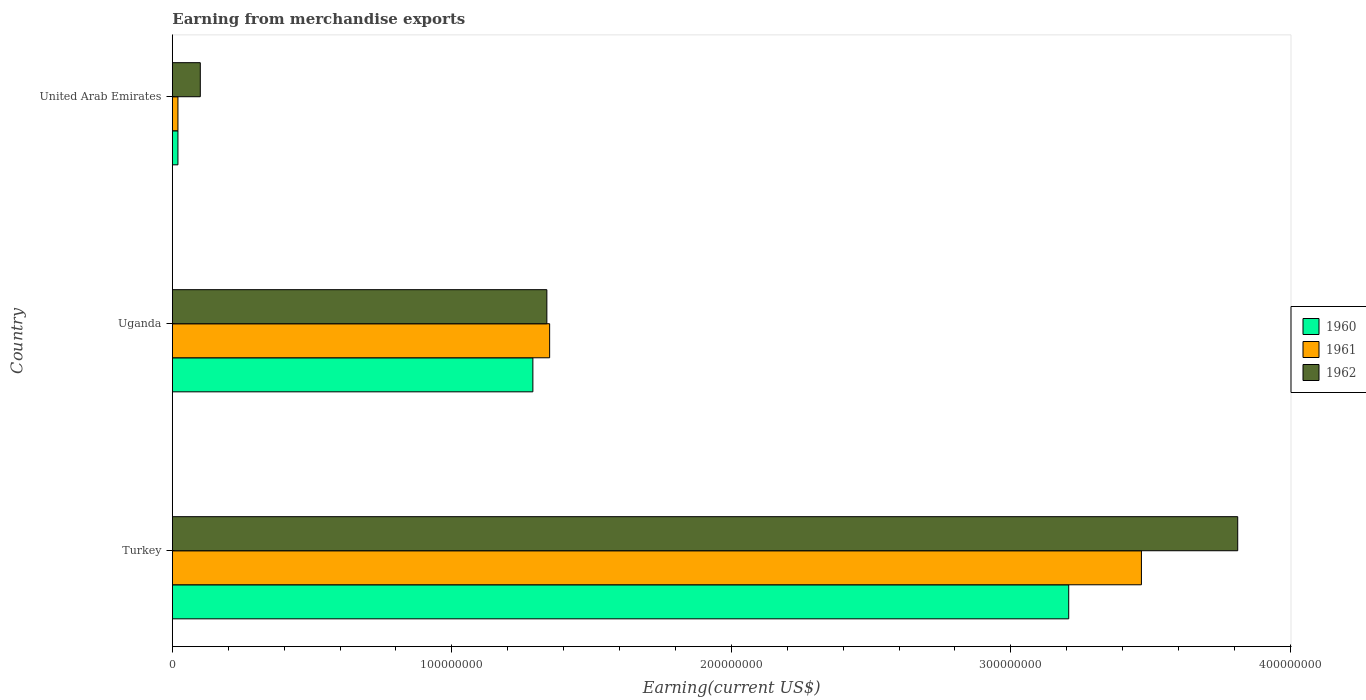How many different coloured bars are there?
Provide a succinct answer. 3. How many groups of bars are there?
Provide a short and direct response. 3. Are the number of bars per tick equal to the number of legend labels?
Offer a very short reply. Yes. Are the number of bars on each tick of the Y-axis equal?
Provide a succinct answer. Yes. How many bars are there on the 3rd tick from the top?
Offer a terse response. 3. How many bars are there on the 1st tick from the bottom?
Provide a succinct answer. 3. What is the label of the 1st group of bars from the top?
Keep it short and to the point. United Arab Emirates. What is the amount earned from merchandise exports in 1962 in Turkey?
Your answer should be very brief. 3.81e+08. Across all countries, what is the maximum amount earned from merchandise exports in 1961?
Your response must be concise. 3.47e+08. Across all countries, what is the minimum amount earned from merchandise exports in 1960?
Provide a succinct answer. 2.00e+06. In which country was the amount earned from merchandise exports in 1961 maximum?
Your response must be concise. Turkey. In which country was the amount earned from merchandise exports in 1962 minimum?
Give a very brief answer. United Arab Emirates. What is the total amount earned from merchandise exports in 1960 in the graph?
Keep it short and to the point. 4.52e+08. What is the difference between the amount earned from merchandise exports in 1961 in Uganda and that in United Arab Emirates?
Provide a short and direct response. 1.33e+08. What is the difference between the amount earned from merchandise exports in 1962 in Uganda and the amount earned from merchandise exports in 1960 in Turkey?
Ensure brevity in your answer.  -1.87e+08. What is the average amount earned from merchandise exports in 1962 per country?
Make the answer very short. 1.75e+08. What is the difference between the amount earned from merchandise exports in 1962 and amount earned from merchandise exports in 1960 in United Arab Emirates?
Ensure brevity in your answer.  8.00e+06. In how many countries, is the amount earned from merchandise exports in 1961 greater than 380000000 US$?
Provide a succinct answer. 0. What is the ratio of the amount earned from merchandise exports in 1960 in Turkey to that in Uganda?
Ensure brevity in your answer.  2.49. Is the amount earned from merchandise exports in 1960 in Uganda less than that in United Arab Emirates?
Your answer should be compact. No. What is the difference between the highest and the second highest amount earned from merchandise exports in 1960?
Offer a very short reply. 1.92e+08. What is the difference between the highest and the lowest amount earned from merchandise exports in 1962?
Your response must be concise. 3.71e+08. What does the 1st bar from the top in Turkey represents?
Give a very brief answer. 1962. What does the 2nd bar from the bottom in Turkey represents?
Make the answer very short. 1961. Does the graph contain any zero values?
Ensure brevity in your answer.  No. Does the graph contain grids?
Ensure brevity in your answer.  No. Where does the legend appear in the graph?
Provide a short and direct response. Center right. How many legend labels are there?
Your answer should be very brief. 3. How are the legend labels stacked?
Give a very brief answer. Vertical. What is the title of the graph?
Your response must be concise. Earning from merchandise exports. What is the label or title of the X-axis?
Offer a terse response. Earning(current US$). What is the Earning(current US$) of 1960 in Turkey?
Provide a succinct answer. 3.21e+08. What is the Earning(current US$) in 1961 in Turkey?
Keep it short and to the point. 3.47e+08. What is the Earning(current US$) in 1962 in Turkey?
Offer a very short reply. 3.81e+08. What is the Earning(current US$) in 1960 in Uganda?
Offer a very short reply. 1.29e+08. What is the Earning(current US$) in 1961 in Uganda?
Give a very brief answer. 1.35e+08. What is the Earning(current US$) of 1962 in Uganda?
Provide a succinct answer. 1.34e+08. What is the Earning(current US$) of 1961 in United Arab Emirates?
Ensure brevity in your answer.  2.00e+06. Across all countries, what is the maximum Earning(current US$) in 1960?
Your response must be concise. 3.21e+08. Across all countries, what is the maximum Earning(current US$) of 1961?
Give a very brief answer. 3.47e+08. Across all countries, what is the maximum Earning(current US$) of 1962?
Provide a succinct answer. 3.81e+08. Across all countries, what is the minimum Earning(current US$) in 1960?
Your answer should be very brief. 2.00e+06. What is the total Earning(current US$) of 1960 in the graph?
Keep it short and to the point. 4.52e+08. What is the total Earning(current US$) of 1961 in the graph?
Offer a terse response. 4.84e+08. What is the total Earning(current US$) in 1962 in the graph?
Provide a succinct answer. 5.25e+08. What is the difference between the Earning(current US$) of 1960 in Turkey and that in Uganda?
Offer a terse response. 1.92e+08. What is the difference between the Earning(current US$) of 1961 in Turkey and that in Uganda?
Give a very brief answer. 2.12e+08. What is the difference between the Earning(current US$) of 1962 in Turkey and that in Uganda?
Your response must be concise. 2.47e+08. What is the difference between the Earning(current US$) in 1960 in Turkey and that in United Arab Emirates?
Make the answer very short. 3.19e+08. What is the difference between the Earning(current US$) in 1961 in Turkey and that in United Arab Emirates?
Your response must be concise. 3.45e+08. What is the difference between the Earning(current US$) of 1962 in Turkey and that in United Arab Emirates?
Make the answer very short. 3.71e+08. What is the difference between the Earning(current US$) of 1960 in Uganda and that in United Arab Emirates?
Your answer should be compact. 1.27e+08. What is the difference between the Earning(current US$) of 1961 in Uganda and that in United Arab Emirates?
Your response must be concise. 1.33e+08. What is the difference between the Earning(current US$) in 1962 in Uganda and that in United Arab Emirates?
Provide a succinct answer. 1.24e+08. What is the difference between the Earning(current US$) of 1960 in Turkey and the Earning(current US$) of 1961 in Uganda?
Offer a terse response. 1.86e+08. What is the difference between the Earning(current US$) in 1960 in Turkey and the Earning(current US$) in 1962 in Uganda?
Ensure brevity in your answer.  1.87e+08. What is the difference between the Earning(current US$) in 1961 in Turkey and the Earning(current US$) in 1962 in Uganda?
Your response must be concise. 2.13e+08. What is the difference between the Earning(current US$) of 1960 in Turkey and the Earning(current US$) of 1961 in United Arab Emirates?
Make the answer very short. 3.19e+08. What is the difference between the Earning(current US$) in 1960 in Turkey and the Earning(current US$) in 1962 in United Arab Emirates?
Offer a very short reply. 3.11e+08. What is the difference between the Earning(current US$) in 1961 in Turkey and the Earning(current US$) in 1962 in United Arab Emirates?
Make the answer very short. 3.37e+08. What is the difference between the Earning(current US$) of 1960 in Uganda and the Earning(current US$) of 1961 in United Arab Emirates?
Ensure brevity in your answer.  1.27e+08. What is the difference between the Earning(current US$) of 1960 in Uganda and the Earning(current US$) of 1962 in United Arab Emirates?
Ensure brevity in your answer.  1.19e+08. What is the difference between the Earning(current US$) in 1961 in Uganda and the Earning(current US$) in 1962 in United Arab Emirates?
Your answer should be very brief. 1.25e+08. What is the average Earning(current US$) of 1960 per country?
Give a very brief answer. 1.51e+08. What is the average Earning(current US$) of 1961 per country?
Your answer should be very brief. 1.61e+08. What is the average Earning(current US$) in 1962 per country?
Offer a terse response. 1.75e+08. What is the difference between the Earning(current US$) of 1960 and Earning(current US$) of 1961 in Turkey?
Your response must be concise. -2.60e+07. What is the difference between the Earning(current US$) of 1960 and Earning(current US$) of 1962 in Turkey?
Make the answer very short. -6.05e+07. What is the difference between the Earning(current US$) in 1961 and Earning(current US$) in 1962 in Turkey?
Provide a succinct answer. -3.45e+07. What is the difference between the Earning(current US$) in 1960 and Earning(current US$) in 1961 in Uganda?
Give a very brief answer. -6.00e+06. What is the difference between the Earning(current US$) in 1960 and Earning(current US$) in 1962 in Uganda?
Provide a short and direct response. -5.00e+06. What is the difference between the Earning(current US$) in 1961 and Earning(current US$) in 1962 in Uganda?
Your answer should be very brief. 1.00e+06. What is the difference between the Earning(current US$) of 1960 and Earning(current US$) of 1961 in United Arab Emirates?
Make the answer very short. 0. What is the difference between the Earning(current US$) in 1960 and Earning(current US$) in 1962 in United Arab Emirates?
Offer a terse response. -8.00e+06. What is the difference between the Earning(current US$) of 1961 and Earning(current US$) of 1962 in United Arab Emirates?
Provide a short and direct response. -8.00e+06. What is the ratio of the Earning(current US$) in 1960 in Turkey to that in Uganda?
Provide a short and direct response. 2.49. What is the ratio of the Earning(current US$) in 1961 in Turkey to that in Uganda?
Ensure brevity in your answer.  2.57. What is the ratio of the Earning(current US$) of 1962 in Turkey to that in Uganda?
Provide a short and direct response. 2.84. What is the ratio of the Earning(current US$) of 1960 in Turkey to that in United Arab Emirates?
Ensure brevity in your answer.  160.37. What is the ratio of the Earning(current US$) in 1961 in Turkey to that in United Arab Emirates?
Ensure brevity in your answer.  173.37. What is the ratio of the Earning(current US$) of 1962 in Turkey to that in United Arab Emirates?
Provide a short and direct response. 38.12. What is the ratio of the Earning(current US$) in 1960 in Uganda to that in United Arab Emirates?
Your answer should be compact. 64.5. What is the ratio of the Earning(current US$) of 1961 in Uganda to that in United Arab Emirates?
Offer a very short reply. 67.5. What is the difference between the highest and the second highest Earning(current US$) of 1960?
Offer a terse response. 1.92e+08. What is the difference between the highest and the second highest Earning(current US$) in 1961?
Offer a terse response. 2.12e+08. What is the difference between the highest and the second highest Earning(current US$) of 1962?
Make the answer very short. 2.47e+08. What is the difference between the highest and the lowest Earning(current US$) of 1960?
Offer a very short reply. 3.19e+08. What is the difference between the highest and the lowest Earning(current US$) in 1961?
Provide a succinct answer. 3.45e+08. What is the difference between the highest and the lowest Earning(current US$) in 1962?
Your answer should be compact. 3.71e+08. 